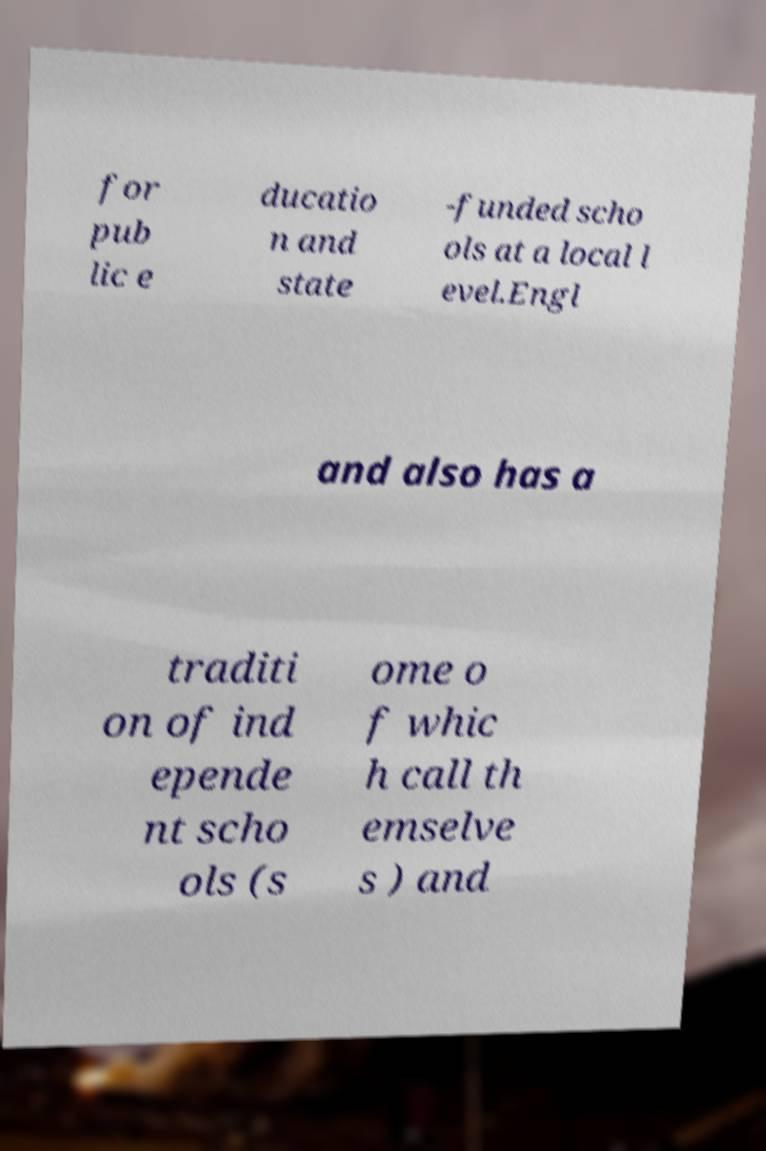Could you extract and type out the text from this image? for pub lic e ducatio n and state -funded scho ols at a local l evel.Engl and also has a traditi on of ind epende nt scho ols (s ome o f whic h call th emselve s ) and 